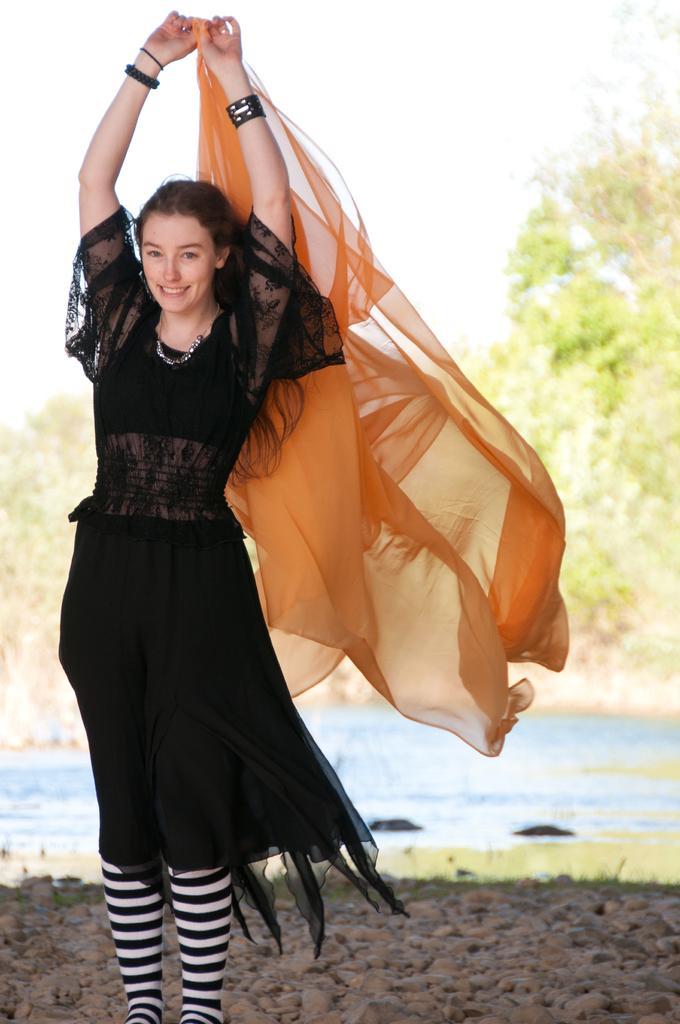In one or two sentences, can you explain what this image depicts? In this image there is one woman standing and smiling and she is holding some cloth, and in the background there are some trees. At the bottom there are some stones and lake. 